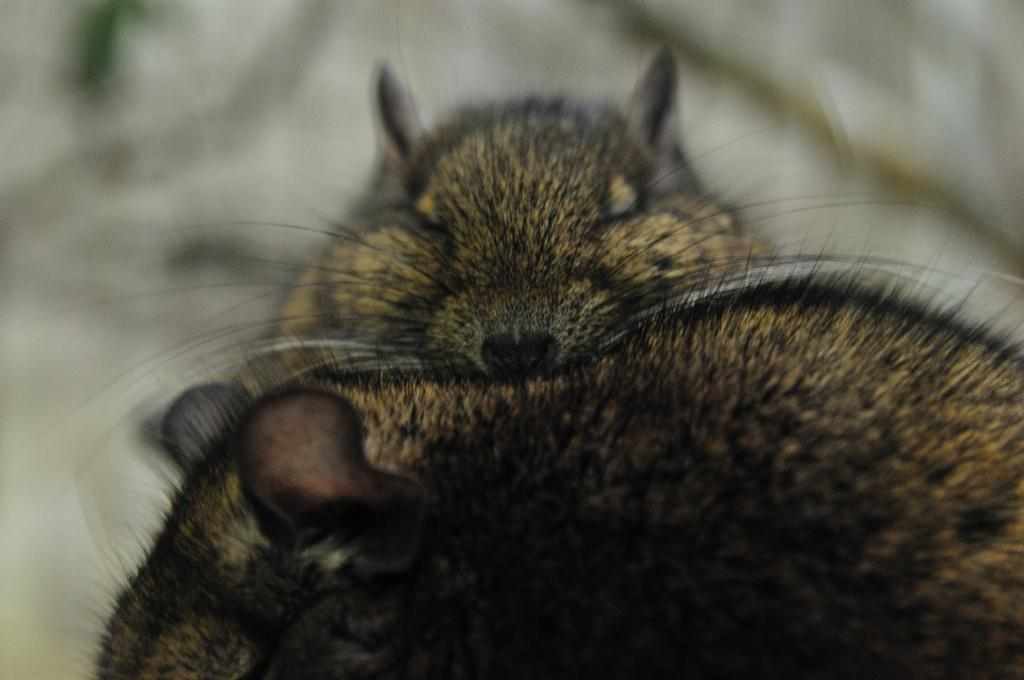What type of animals are present in the image? There are rats in the image. Reasoning: Let's think step by step by step in order to produce the conversation. We start by identifying the main subject in the image, which is the rats. Since there is only one fact provided, we formulate a question that focuses on the type of animals present in the image. We ensure that the language is simple and clear, and that the question can be answered definitively with the information given. Absurd Question/Answer: What type of fan is being used by the rats in the image? There is no fan present in the image; it only features rats. 